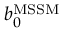Convert formula to latex. <formula><loc_0><loc_0><loc_500><loc_500>b _ { 0 } ^ { M S S M }</formula> 